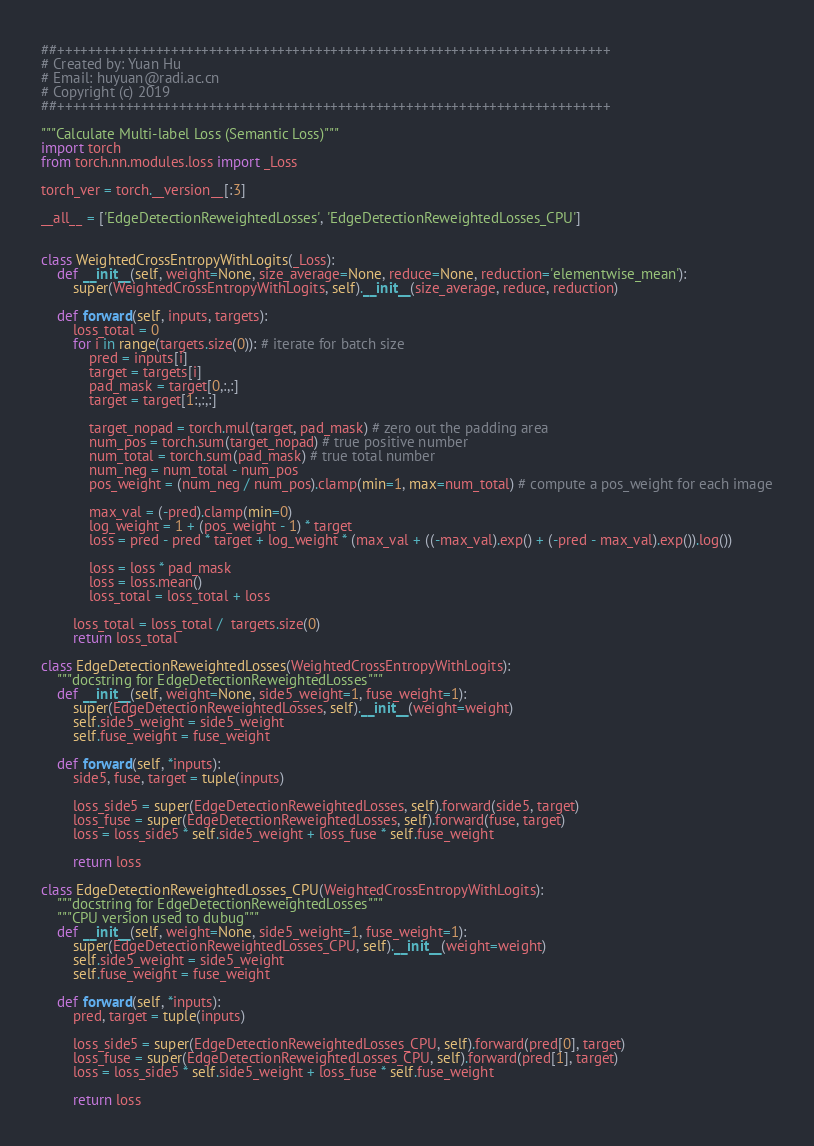<code> <loc_0><loc_0><loc_500><loc_500><_Python_>##+++++++++++++++++++++++++++++++++++++++++++++++++++++++++++++++++++++++++
# Created by: Yuan Hu
# Email: huyuan@radi.ac.cn
# Copyright (c) 2019
##+++++++++++++++++++++++++++++++++++++++++++++++++++++++++++++++++++++++++

"""Calculate Multi-label Loss (Semantic Loss)"""
import torch
from torch.nn.modules.loss import _Loss

torch_ver = torch.__version__[:3]

__all__ = ['EdgeDetectionReweightedLosses', 'EdgeDetectionReweightedLosses_CPU']


class WeightedCrossEntropyWithLogits(_Loss):
    def __init__(self, weight=None, size_average=None, reduce=None, reduction='elementwise_mean'):
        super(WeightedCrossEntropyWithLogits, self).__init__(size_average, reduce, reduction)

    def forward(self, inputs, targets):
        loss_total = 0
        for i in range(targets.size(0)): # iterate for batch size
            pred = inputs[i]
            target = targets[i]
            pad_mask = target[0,:,:]
            target = target[1:,:,:]

            target_nopad = torch.mul(target, pad_mask) # zero out the padding area
            num_pos = torch.sum(target_nopad) # true positive number
            num_total = torch.sum(pad_mask) # true total number
            num_neg = num_total - num_pos
            pos_weight = (num_neg / num_pos).clamp(min=1, max=num_total) # compute a pos_weight for each image

            max_val = (-pred).clamp(min=0)
            log_weight = 1 + (pos_weight - 1) * target
            loss = pred - pred * target + log_weight * (max_val + ((-max_val).exp() + (-pred - max_val).exp()).log())

            loss = loss * pad_mask
            loss = loss.mean()
            loss_total = loss_total + loss

        loss_total = loss_total /  targets.size(0)
        return loss_total

class EdgeDetectionReweightedLosses(WeightedCrossEntropyWithLogits):
    """docstring for EdgeDetectionReweightedLosses"""
    def __init__(self, weight=None, side5_weight=1, fuse_weight=1):
        super(EdgeDetectionReweightedLosses, self).__init__(weight=weight)
        self.side5_weight = side5_weight
        self.fuse_weight = fuse_weight

    def forward(self, *inputs):
        side5, fuse, target = tuple(inputs)

        loss_side5 = super(EdgeDetectionReweightedLosses, self).forward(side5, target)
        loss_fuse = super(EdgeDetectionReweightedLosses, self).forward(fuse, target)
        loss = loss_side5 * self.side5_weight + loss_fuse * self.fuse_weight

        return loss

class EdgeDetectionReweightedLosses_CPU(WeightedCrossEntropyWithLogits):
    """docstring for EdgeDetectionReweightedLosses"""
    """CPU version used to dubug"""
    def __init__(self, weight=None, side5_weight=1, fuse_weight=1):
        super(EdgeDetectionReweightedLosses_CPU, self).__init__(weight=weight)
        self.side5_weight = side5_weight
        self.fuse_weight = fuse_weight

    def forward(self, *inputs):
        pred, target = tuple(inputs)

        loss_side5 = super(EdgeDetectionReweightedLosses_CPU, self).forward(pred[0], target)
        loss_fuse = super(EdgeDetectionReweightedLosses_CPU, self).forward(pred[1], target)
        loss = loss_side5 * self.side5_weight + loss_fuse * self.fuse_weight

        return loss
</code> 